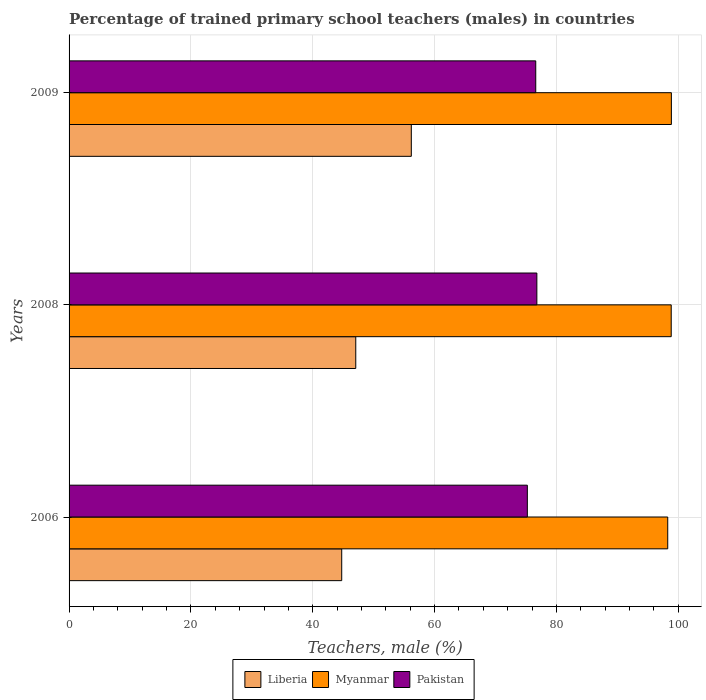How many bars are there on the 1st tick from the top?
Ensure brevity in your answer.  3. What is the label of the 3rd group of bars from the top?
Make the answer very short. 2006. What is the percentage of trained primary school teachers (males) in Pakistan in 2008?
Keep it short and to the point. 76.79. Across all years, what is the maximum percentage of trained primary school teachers (males) in Myanmar?
Offer a very short reply. 98.87. Across all years, what is the minimum percentage of trained primary school teachers (males) in Liberia?
Keep it short and to the point. 44.76. In which year was the percentage of trained primary school teachers (males) in Liberia minimum?
Keep it short and to the point. 2006. What is the total percentage of trained primary school teachers (males) in Pakistan in the graph?
Provide a short and direct response. 228.62. What is the difference between the percentage of trained primary school teachers (males) in Liberia in 2006 and that in 2008?
Give a very brief answer. -2.31. What is the difference between the percentage of trained primary school teachers (males) in Liberia in 2006 and the percentage of trained primary school teachers (males) in Pakistan in 2008?
Keep it short and to the point. -32.03. What is the average percentage of trained primary school teachers (males) in Pakistan per year?
Your answer should be very brief. 76.21. In the year 2006, what is the difference between the percentage of trained primary school teachers (males) in Liberia and percentage of trained primary school teachers (males) in Pakistan?
Offer a very short reply. -30.47. What is the ratio of the percentage of trained primary school teachers (males) in Liberia in 2006 to that in 2009?
Your response must be concise. 0.8. Is the percentage of trained primary school teachers (males) in Liberia in 2008 less than that in 2009?
Keep it short and to the point. Yes. Is the difference between the percentage of trained primary school teachers (males) in Liberia in 2008 and 2009 greater than the difference between the percentage of trained primary school teachers (males) in Pakistan in 2008 and 2009?
Provide a short and direct response. No. What is the difference between the highest and the second highest percentage of trained primary school teachers (males) in Pakistan?
Provide a succinct answer. 0.18. What is the difference between the highest and the lowest percentage of trained primary school teachers (males) in Pakistan?
Ensure brevity in your answer.  1.56. In how many years, is the percentage of trained primary school teachers (males) in Myanmar greater than the average percentage of trained primary school teachers (males) in Myanmar taken over all years?
Give a very brief answer. 2. What does the 1st bar from the top in 2009 represents?
Make the answer very short. Pakistan. What does the 1st bar from the bottom in 2008 represents?
Provide a succinct answer. Liberia. Is it the case that in every year, the sum of the percentage of trained primary school teachers (males) in Liberia and percentage of trained primary school teachers (males) in Pakistan is greater than the percentage of trained primary school teachers (males) in Myanmar?
Give a very brief answer. Yes. How many years are there in the graph?
Your response must be concise. 3. Are the values on the major ticks of X-axis written in scientific E-notation?
Your response must be concise. No. Does the graph contain any zero values?
Your answer should be compact. No. Where does the legend appear in the graph?
Offer a terse response. Bottom center. What is the title of the graph?
Your answer should be compact. Percentage of trained primary school teachers (males) in countries. What is the label or title of the X-axis?
Offer a terse response. Teachers, male (%). What is the Teachers, male (%) in Liberia in 2006?
Make the answer very short. 44.76. What is the Teachers, male (%) of Myanmar in 2006?
Keep it short and to the point. 98.27. What is the Teachers, male (%) in Pakistan in 2006?
Your answer should be very brief. 75.23. What is the Teachers, male (%) of Liberia in 2008?
Keep it short and to the point. 47.06. What is the Teachers, male (%) in Myanmar in 2008?
Provide a succinct answer. 98.84. What is the Teachers, male (%) of Pakistan in 2008?
Ensure brevity in your answer.  76.79. What is the Teachers, male (%) of Liberia in 2009?
Provide a succinct answer. 56.18. What is the Teachers, male (%) in Myanmar in 2009?
Your answer should be compact. 98.87. What is the Teachers, male (%) of Pakistan in 2009?
Your response must be concise. 76.61. Across all years, what is the maximum Teachers, male (%) in Liberia?
Offer a terse response. 56.18. Across all years, what is the maximum Teachers, male (%) of Myanmar?
Give a very brief answer. 98.87. Across all years, what is the maximum Teachers, male (%) of Pakistan?
Offer a terse response. 76.79. Across all years, what is the minimum Teachers, male (%) of Liberia?
Provide a succinct answer. 44.76. Across all years, what is the minimum Teachers, male (%) of Myanmar?
Your answer should be very brief. 98.27. Across all years, what is the minimum Teachers, male (%) of Pakistan?
Give a very brief answer. 75.23. What is the total Teachers, male (%) in Liberia in the graph?
Offer a terse response. 148. What is the total Teachers, male (%) in Myanmar in the graph?
Offer a very short reply. 295.98. What is the total Teachers, male (%) of Pakistan in the graph?
Your response must be concise. 228.62. What is the difference between the Teachers, male (%) of Liberia in 2006 and that in 2008?
Provide a short and direct response. -2.31. What is the difference between the Teachers, male (%) in Myanmar in 2006 and that in 2008?
Offer a terse response. -0.57. What is the difference between the Teachers, male (%) of Pakistan in 2006 and that in 2008?
Offer a very short reply. -1.56. What is the difference between the Teachers, male (%) in Liberia in 2006 and that in 2009?
Your answer should be very brief. -11.43. What is the difference between the Teachers, male (%) in Myanmar in 2006 and that in 2009?
Your answer should be compact. -0.6. What is the difference between the Teachers, male (%) in Pakistan in 2006 and that in 2009?
Your response must be concise. -1.38. What is the difference between the Teachers, male (%) in Liberia in 2008 and that in 2009?
Your response must be concise. -9.12. What is the difference between the Teachers, male (%) of Myanmar in 2008 and that in 2009?
Your answer should be very brief. -0.03. What is the difference between the Teachers, male (%) in Pakistan in 2008 and that in 2009?
Your answer should be compact. 0.18. What is the difference between the Teachers, male (%) of Liberia in 2006 and the Teachers, male (%) of Myanmar in 2008?
Ensure brevity in your answer.  -54.09. What is the difference between the Teachers, male (%) of Liberia in 2006 and the Teachers, male (%) of Pakistan in 2008?
Give a very brief answer. -32.03. What is the difference between the Teachers, male (%) of Myanmar in 2006 and the Teachers, male (%) of Pakistan in 2008?
Offer a terse response. 21.48. What is the difference between the Teachers, male (%) in Liberia in 2006 and the Teachers, male (%) in Myanmar in 2009?
Your answer should be compact. -54.11. What is the difference between the Teachers, male (%) in Liberia in 2006 and the Teachers, male (%) in Pakistan in 2009?
Your answer should be compact. -31.85. What is the difference between the Teachers, male (%) of Myanmar in 2006 and the Teachers, male (%) of Pakistan in 2009?
Your answer should be compact. 21.67. What is the difference between the Teachers, male (%) in Liberia in 2008 and the Teachers, male (%) in Myanmar in 2009?
Ensure brevity in your answer.  -51.81. What is the difference between the Teachers, male (%) of Liberia in 2008 and the Teachers, male (%) of Pakistan in 2009?
Your response must be concise. -29.54. What is the difference between the Teachers, male (%) in Myanmar in 2008 and the Teachers, male (%) in Pakistan in 2009?
Your answer should be compact. 22.24. What is the average Teachers, male (%) in Liberia per year?
Offer a very short reply. 49.33. What is the average Teachers, male (%) of Myanmar per year?
Give a very brief answer. 98.66. What is the average Teachers, male (%) of Pakistan per year?
Your answer should be compact. 76.21. In the year 2006, what is the difference between the Teachers, male (%) in Liberia and Teachers, male (%) in Myanmar?
Keep it short and to the point. -53.52. In the year 2006, what is the difference between the Teachers, male (%) in Liberia and Teachers, male (%) in Pakistan?
Give a very brief answer. -30.47. In the year 2006, what is the difference between the Teachers, male (%) of Myanmar and Teachers, male (%) of Pakistan?
Give a very brief answer. 23.04. In the year 2008, what is the difference between the Teachers, male (%) in Liberia and Teachers, male (%) in Myanmar?
Offer a very short reply. -51.78. In the year 2008, what is the difference between the Teachers, male (%) in Liberia and Teachers, male (%) in Pakistan?
Keep it short and to the point. -29.73. In the year 2008, what is the difference between the Teachers, male (%) of Myanmar and Teachers, male (%) of Pakistan?
Provide a succinct answer. 22.06. In the year 2009, what is the difference between the Teachers, male (%) in Liberia and Teachers, male (%) in Myanmar?
Provide a short and direct response. -42.69. In the year 2009, what is the difference between the Teachers, male (%) of Liberia and Teachers, male (%) of Pakistan?
Provide a short and direct response. -20.42. In the year 2009, what is the difference between the Teachers, male (%) in Myanmar and Teachers, male (%) in Pakistan?
Your answer should be very brief. 22.26. What is the ratio of the Teachers, male (%) of Liberia in 2006 to that in 2008?
Make the answer very short. 0.95. What is the ratio of the Teachers, male (%) of Myanmar in 2006 to that in 2008?
Make the answer very short. 0.99. What is the ratio of the Teachers, male (%) of Pakistan in 2006 to that in 2008?
Provide a succinct answer. 0.98. What is the ratio of the Teachers, male (%) in Liberia in 2006 to that in 2009?
Ensure brevity in your answer.  0.8. What is the ratio of the Teachers, male (%) in Pakistan in 2006 to that in 2009?
Offer a terse response. 0.98. What is the ratio of the Teachers, male (%) in Liberia in 2008 to that in 2009?
Make the answer very short. 0.84. What is the difference between the highest and the second highest Teachers, male (%) of Liberia?
Your answer should be compact. 9.12. What is the difference between the highest and the second highest Teachers, male (%) of Myanmar?
Your response must be concise. 0.03. What is the difference between the highest and the second highest Teachers, male (%) in Pakistan?
Give a very brief answer. 0.18. What is the difference between the highest and the lowest Teachers, male (%) of Liberia?
Offer a terse response. 11.43. What is the difference between the highest and the lowest Teachers, male (%) of Myanmar?
Offer a terse response. 0.6. What is the difference between the highest and the lowest Teachers, male (%) of Pakistan?
Your answer should be very brief. 1.56. 